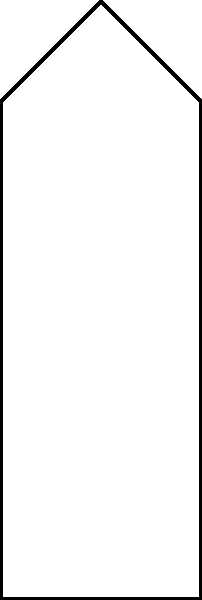In the simplified bone model shown, a vertical force is applied at the top. Based on the stress gradient visualization, which region of the bone experiences the highest stress concentration? Explain why this occurs from a biomechanical perspective. To answer this question, let's analyze the stress distribution step-by-step:

1. Force application: The vertical force is applied at the top of the bone model.

2. Stress distribution: The colors in the image represent stress levels, with red indicating higher stress and blue indicating lower stress.

3. Observation: The highest stress concentration (red area) is located near the center of the bone, slightly below the point of force application.

4. Biomechanical explanation:
   a) Stress concentration: Stress tends to concentrate in areas where there are sudden changes in geometry or cross-sectional area.
   b) Bone shape: The bone model has a wider top and bottom, with a narrower middle section.
   c) Force transmission: As the force is applied at the top, it's transmitted through the bone structure.
   d) Narrowing effect: The narrower middle section experiences higher stress due to the same force being distributed over a smaller cross-sectional area, following the equation:
      $$\text{Stress} = \frac{\text{Force}}{\text{Area}}$$

5. Engineering perspective: This stress distribution is similar to what a software engineer might encounter when optimizing load distribution in a system, where bottlenecks (narrow sections) often experience higher stress or load.

6. DIY relevance: Understanding stress distribution is crucial for DIY enthusiasts when designing and building structures, helping to identify potential weak points and reinforce them appropriately.
Answer: The center region, due to its narrower cross-section. 